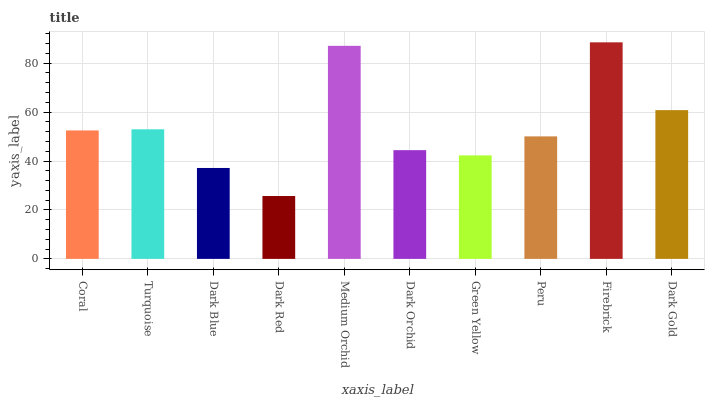Is Dark Red the minimum?
Answer yes or no. Yes. Is Firebrick the maximum?
Answer yes or no. Yes. Is Turquoise the minimum?
Answer yes or no. No. Is Turquoise the maximum?
Answer yes or no. No. Is Turquoise greater than Coral?
Answer yes or no. Yes. Is Coral less than Turquoise?
Answer yes or no. Yes. Is Coral greater than Turquoise?
Answer yes or no. No. Is Turquoise less than Coral?
Answer yes or no. No. Is Coral the high median?
Answer yes or no. Yes. Is Peru the low median?
Answer yes or no. Yes. Is Green Yellow the high median?
Answer yes or no. No. Is Dark Gold the low median?
Answer yes or no. No. 